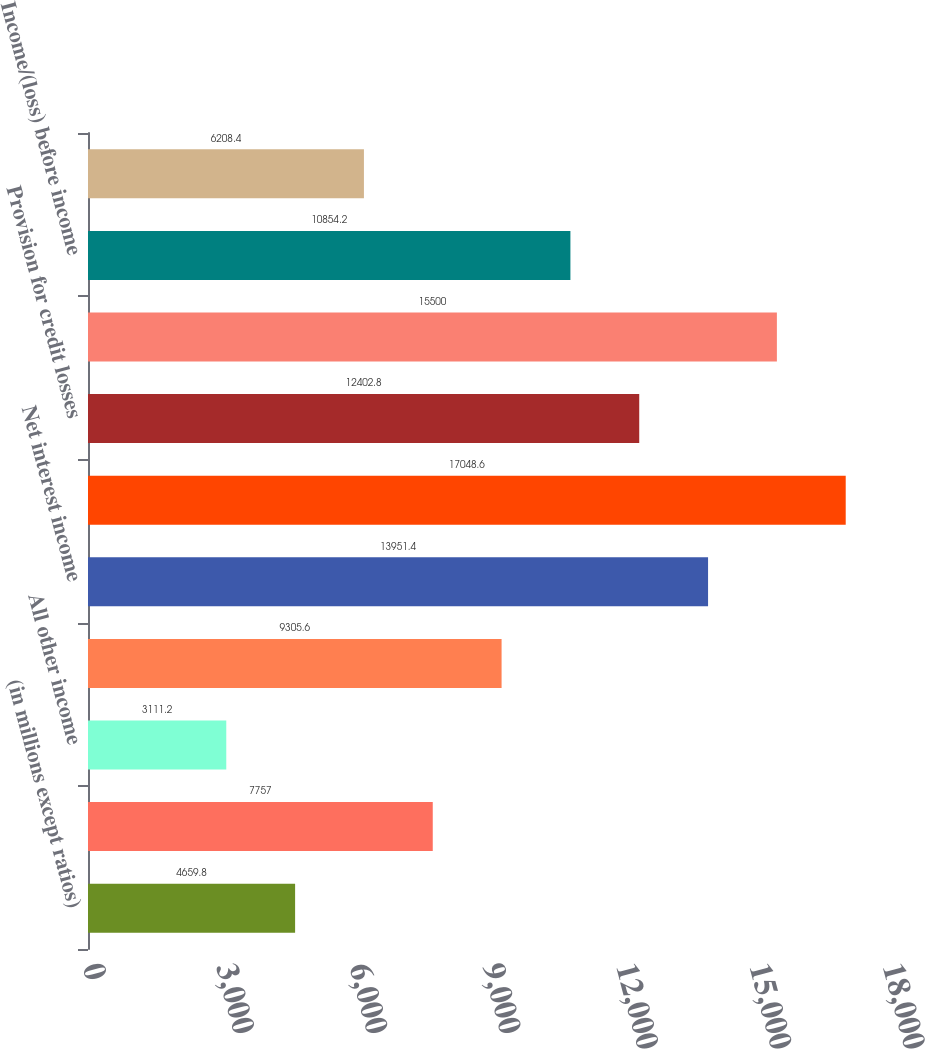Convert chart to OTSL. <chart><loc_0><loc_0><loc_500><loc_500><bar_chart><fcel>(in millions except ratios)<fcel>Mortgage fees and related<fcel>All other income<fcel>Noninterest revenue<fcel>Net interest income<fcel>Total net revenue<fcel>Provision for credit losses<fcel>Noninterest expense<fcel>Income/(loss) before income<fcel>Net income/(loss)<nl><fcel>4659.8<fcel>7757<fcel>3111.2<fcel>9305.6<fcel>13951.4<fcel>17048.6<fcel>12402.8<fcel>15500<fcel>10854.2<fcel>6208.4<nl></chart> 